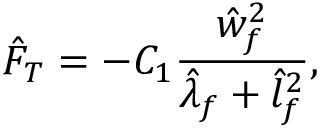Convert formula to latex. <formula><loc_0><loc_0><loc_500><loc_500>\hat { F } _ { T } = - C _ { 1 } \frac { \hat { w } _ { f } ^ { 2 } } { \hat { \lambda } _ { f } + \hat { l } _ { f } ^ { 2 } } ,</formula> 